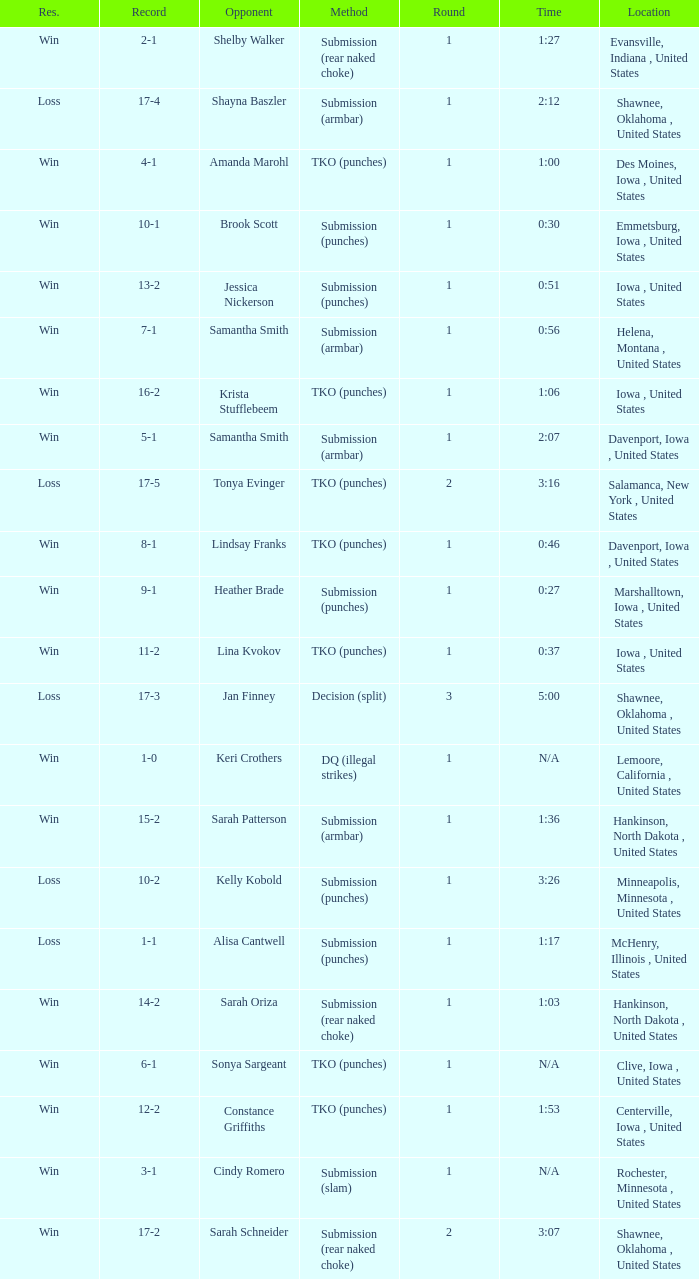Would you be able to parse every entry in this table? {'header': ['Res.', 'Record', 'Opponent', 'Method', 'Round', 'Time', 'Location'], 'rows': [['Win', '2-1', 'Shelby Walker', 'Submission (rear naked choke)', '1', '1:27', 'Evansville, Indiana , United States'], ['Loss', '17-4', 'Shayna Baszler', 'Submission (armbar)', '1', '2:12', 'Shawnee, Oklahoma , United States'], ['Win', '4-1', 'Amanda Marohl', 'TKO (punches)', '1', '1:00', 'Des Moines, Iowa , United States'], ['Win', '10-1', 'Brook Scott', 'Submission (punches)', '1', '0:30', 'Emmetsburg, Iowa , United States'], ['Win', '13-2', 'Jessica Nickerson', 'Submission (punches)', '1', '0:51', 'Iowa , United States'], ['Win', '7-1', 'Samantha Smith', 'Submission (armbar)', '1', '0:56', 'Helena, Montana , United States'], ['Win', '16-2', 'Krista Stufflebeem', 'TKO (punches)', '1', '1:06', 'Iowa , United States'], ['Win', '5-1', 'Samantha Smith', 'Submission (armbar)', '1', '2:07', 'Davenport, Iowa , United States'], ['Loss', '17-5', 'Tonya Evinger', 'TKO (punches)', '2', '3:16', 'Salamanca, New York , United States'], ['Win', '8-1', 'Lindsay Franks', 'TKO (punches)', '1', '0:46', 'Davenport, Iowa , United States'], ['Win', '9-1', 'Heather Brade', 'Submission (punches)', '1', '0:27', 'Marshalltown, Iowa , United States'], ['Win', '11-2', 'Lina Kvokov', 'TKO (punches)', '1', '0:37', 'Iowa , United States'], ['Loss', '17-3', 'Jan Finney', 'Decision (split)', '3', '5:00', 'Shawnee, Oklahoma , United States'], ['Win', '1-0', 'Keri Crothers', 'DQ (illegal strikes)', '1', 'N/A', 'Lemoore, California , United States'], ['Win', '15-2', 'Sarah Patterson', 'Submission (armbar)', '1', '1:36', 'Hankinson, North Dakota , United States'], ['Loss', '10-2', 'Kelly Kobold', 'Submission (punches)', '1', '3:26', 'Minneapolis, Minnesota , United States'], ['Loss', '1-1', 'Alisa Cantwell', 'Submission (punches)', '1', '1:17', 'McHenry, Illinois , United States'], ['Win', '14-2', 'Sarah Oriza', 'Submission (rear naked choke)', '1', '1:03', 'Hankinson, North Dakota , United States'], ['Win', '6-1', 'Sonya Sargeant', 'TKO (punches)', '1', 'N/A', 'Clive, Iowa , United States'], ['Win', '12-2', 'Constance Griffiths', 'TKO (punches)', '1', '1:53', 'Centerville, Iowa , United States'], ['Win', '3-1', 'Cindy Romero', 'Submission (slam)', '1', 'N/A', 'Rochester, Minnesota , United States'], ['Win', '17-2', 'Sarah Schneider', 'Submission (rear naked choke)', '2', '3:07', 'Shawnee, Oklahoma , United States']]} What opponent does she fight when she is 10-1? Brook Scott. 